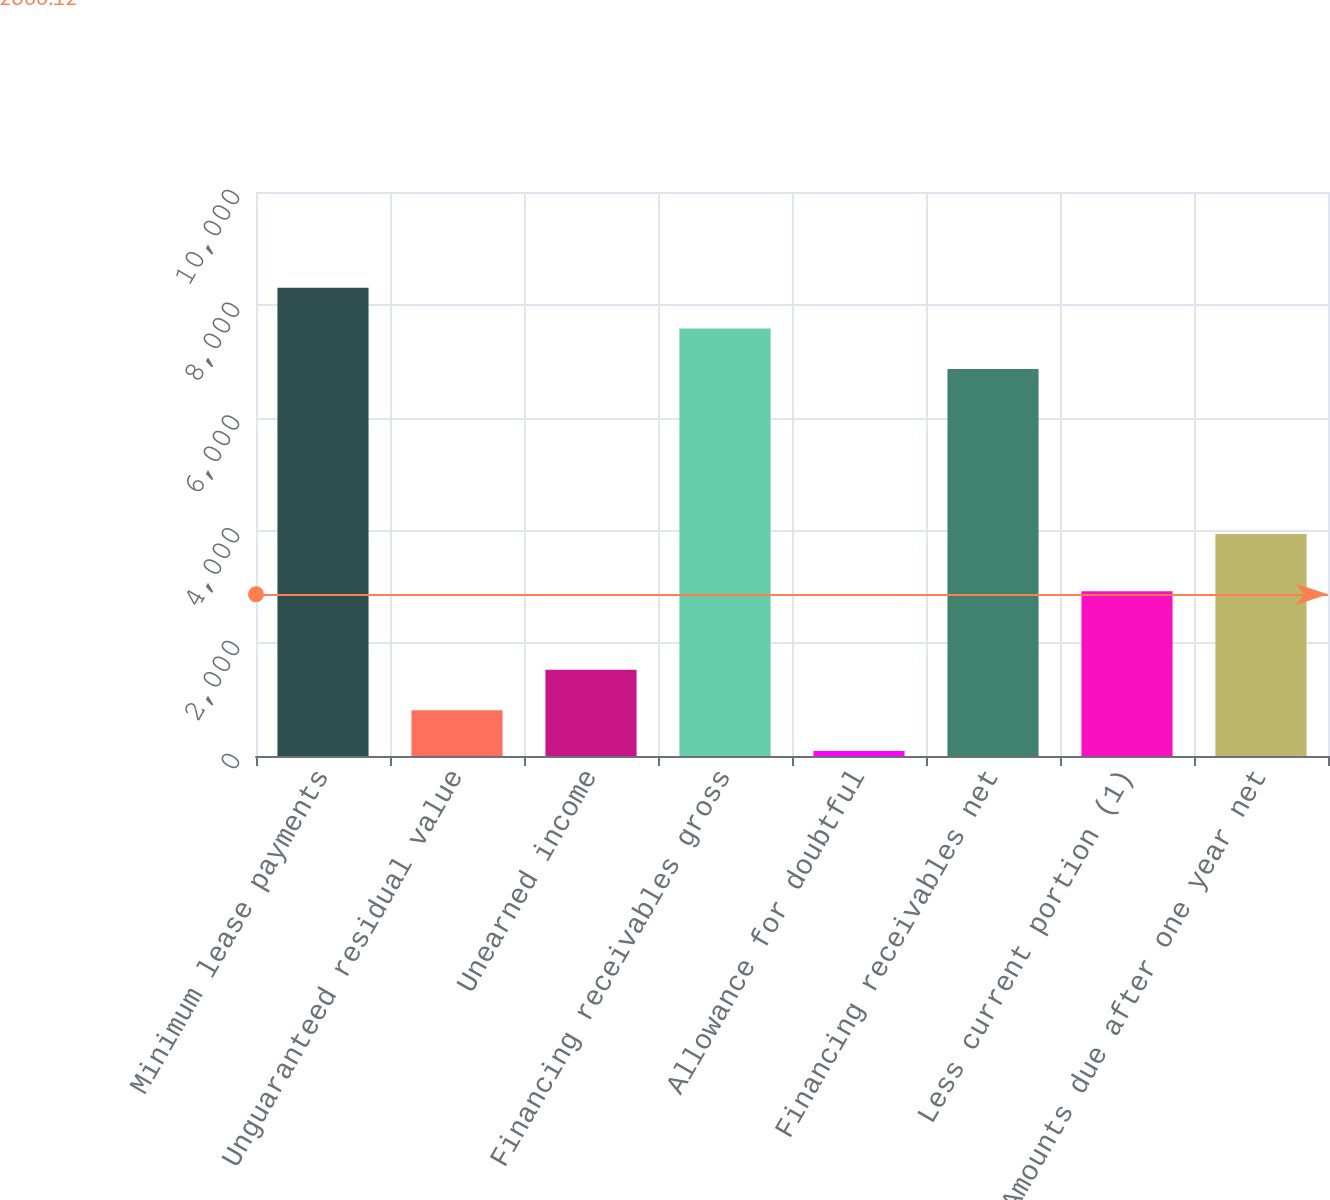<chart> <loc_0><loc_0><loc_500><loc_500><bar_chart><fcel>Minimum lease payments<fcel>Unguaranteed residual value<fcel>Unearned income<fcel>Financing receivables gross<fcel>Allowance for doubtful<fcel>Financing receivables net<fcel>Less current portion (1)<fcel>Amounts due after one year net<nl><fcel>8301.8<fcel>809.4<fcel>1529.8<fcel>7581.4<fcel>89<fcel>6861<fcel>2923<fcel>3938<nl></chart> 